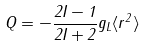Convert formula to latex. <formula><loc_0><loc_0><loc_500><loc_500>Q = - \frac { 2 I - 1 } { 2 I + 2 } g _ { L } \langle r ^ { 2 } \rangle</formula> 